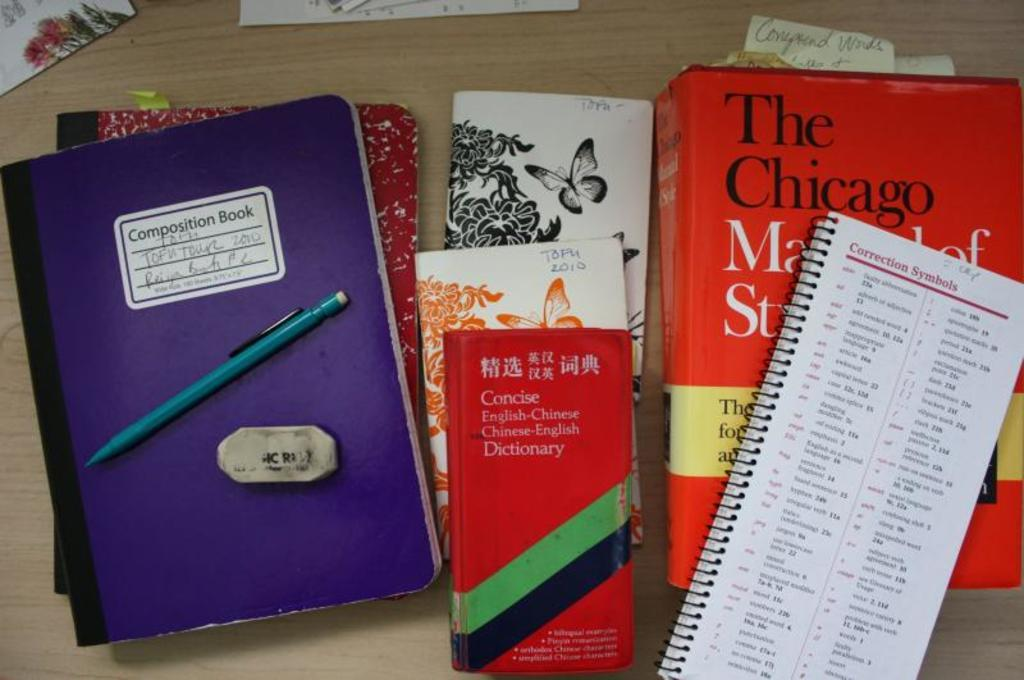<image>
Share a concise interpretation of the image provided. A notebook and several books are laid out together with the word Chicago on the cover of one of the books. 